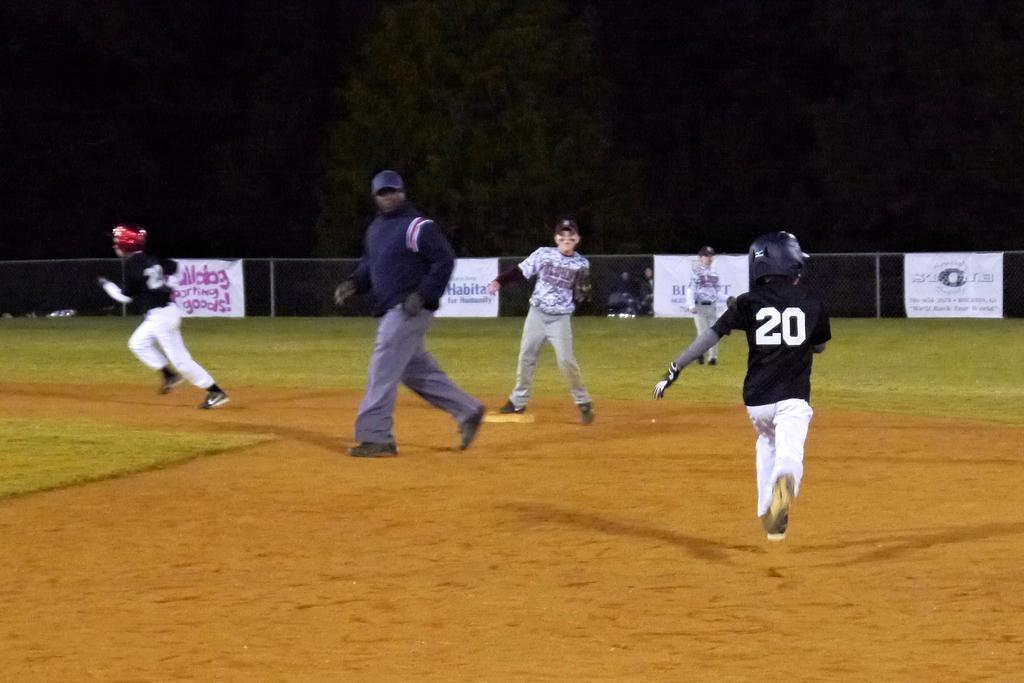Which player number is running on the right?
Keep it short and to the point. 20. 